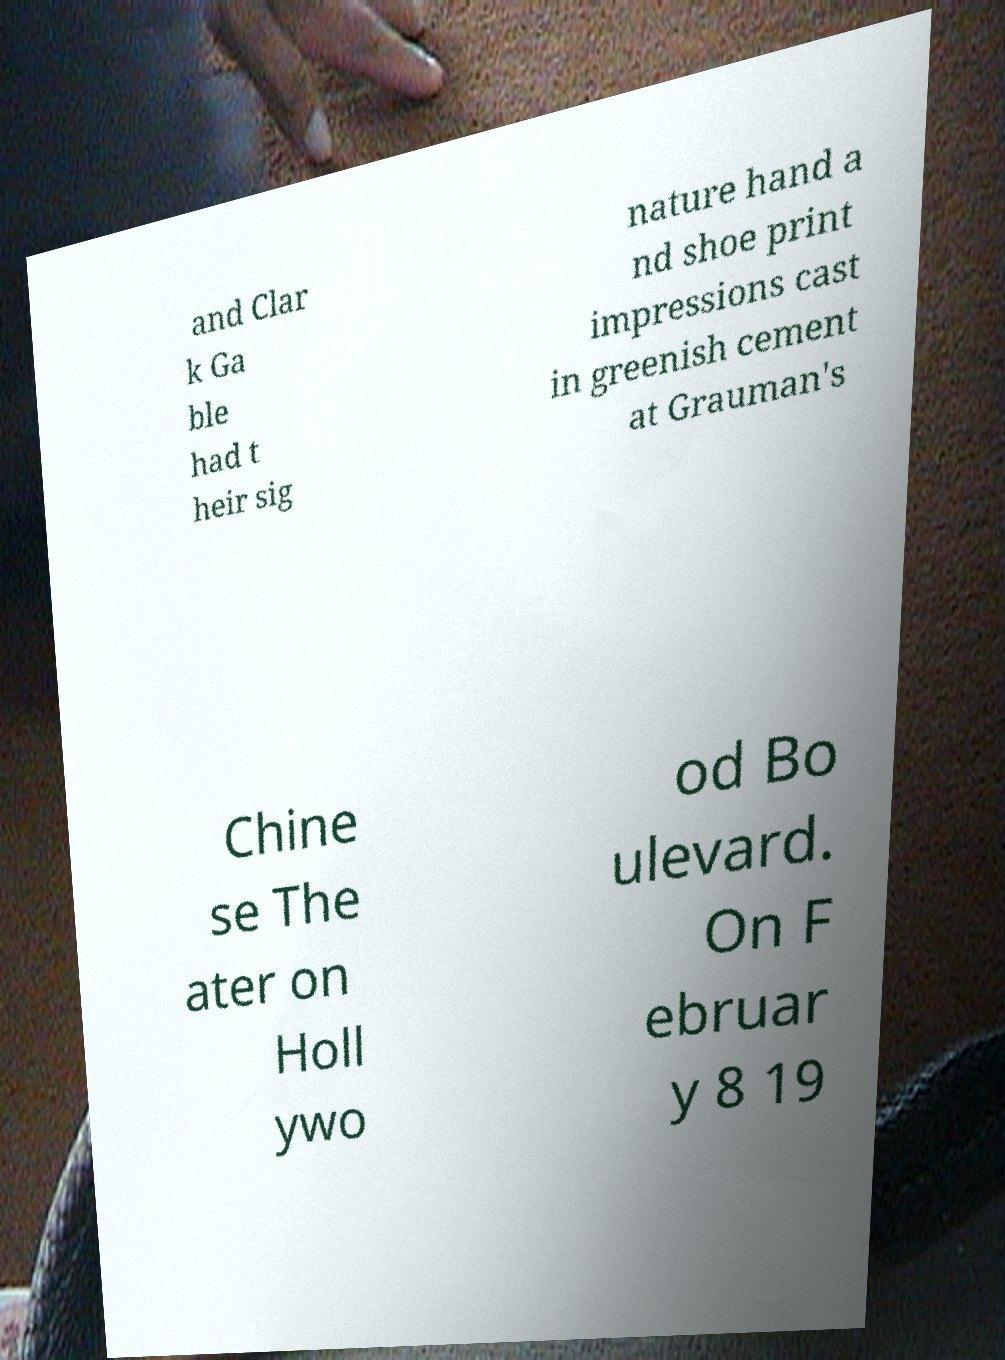Please read and relay the text visible in this image. What does it say? and Clar k Ga ble had t heir sig nature hand a nd shoe print impressions cast in greenish cement at Grauman's Chine se The ater on Holl ywo od Bo ulevard. On F ebruar y 8 19 